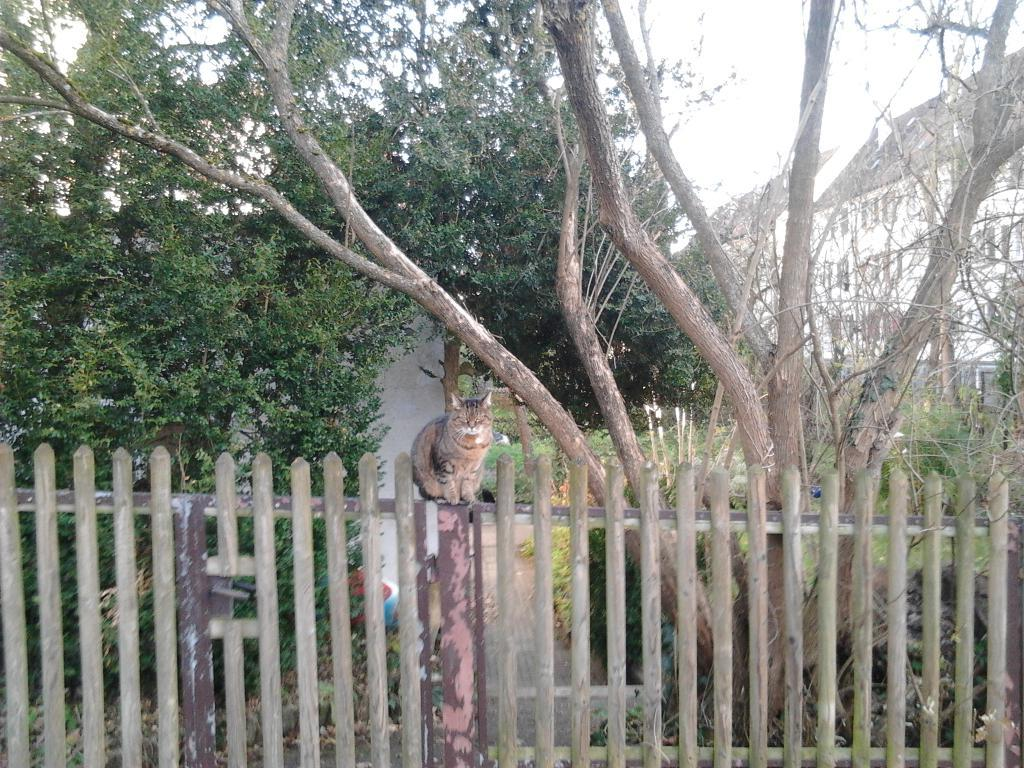What animal is sitting on the fencing in the image? There is a cat sitting on the fencing in the image. What type of vegetation can be seen in the image? There are trees visible in the image. What type of structure is present in the image? There is a house in the image. What is visible at the top of the image? The sky is visible at the top of the image. What type of celery can be seen growing in the image? There is no celery present in the image. What color is the spot on the cat's fur in the image? There is no mention of a spot on the cat's fur in the image, so we cannot determine its color. 